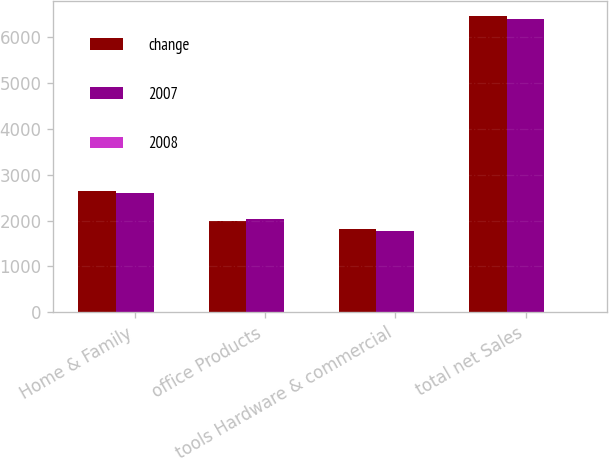Convert chart to OTSL. <chart><loc_0><loc_0><loc_500><loc_500><stacked_bar_chart><ecel><fcel>Home & Family<fcel>office Products<fcel>tools Hardware & commercial<fcel>total net Sales<nl><fcel>change<fcel>2654.8<fcel>1990.8<fcel>1825<fcel>6470.6<nl><fcel>2007<fcel>2610.8<fcel>2026.2<fcel>1770.3<fcel>6407.3<nl><fcel>2008<fcel>1.7<fcel>1.7<fcel>3.1<fcel>1<nl></chart> 